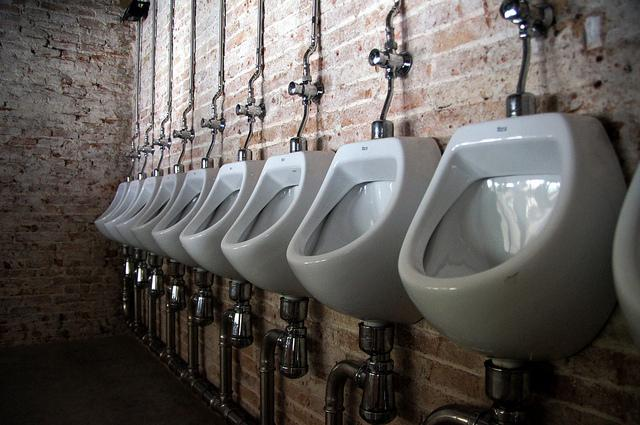What are these white objects used to hold? Please explain your reasoning. urine. These are men's toilets 